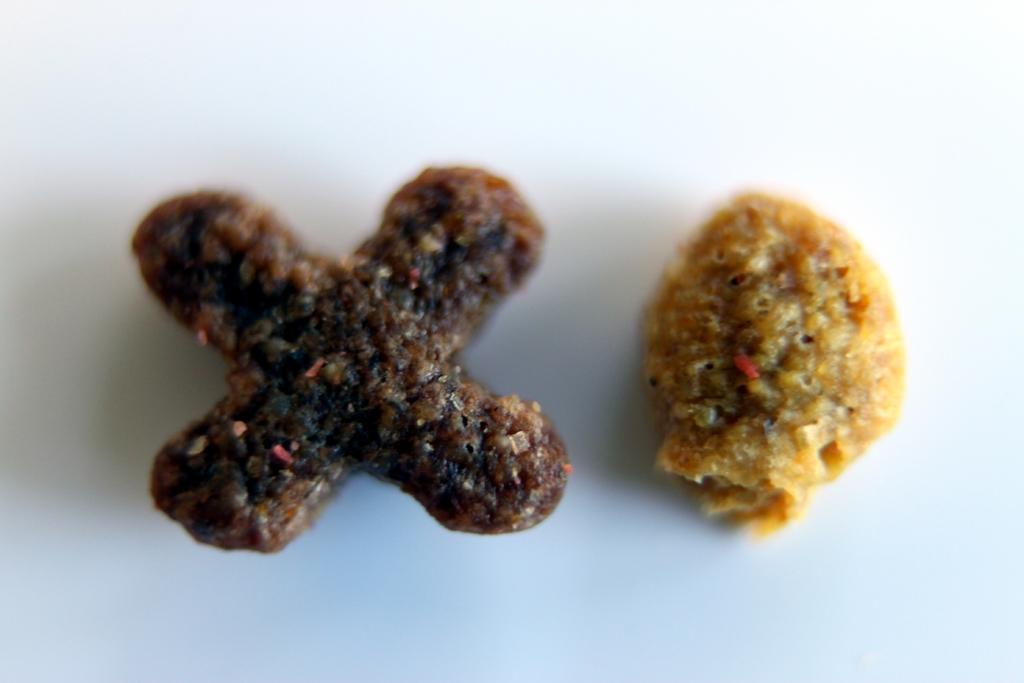How would you summarize this image in a sentence or two? In the image there are two crispy chips in a plate. 